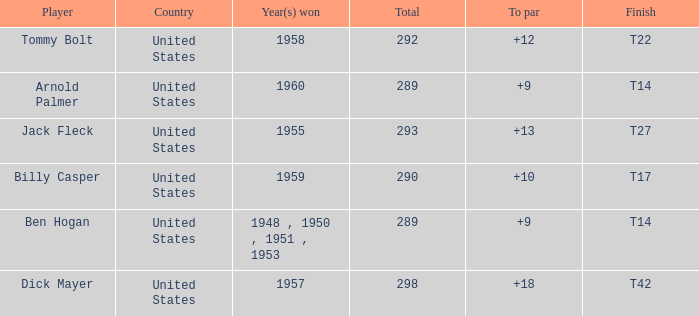What is Player, when Year(s) Won is 1955? Jack Fleck. 